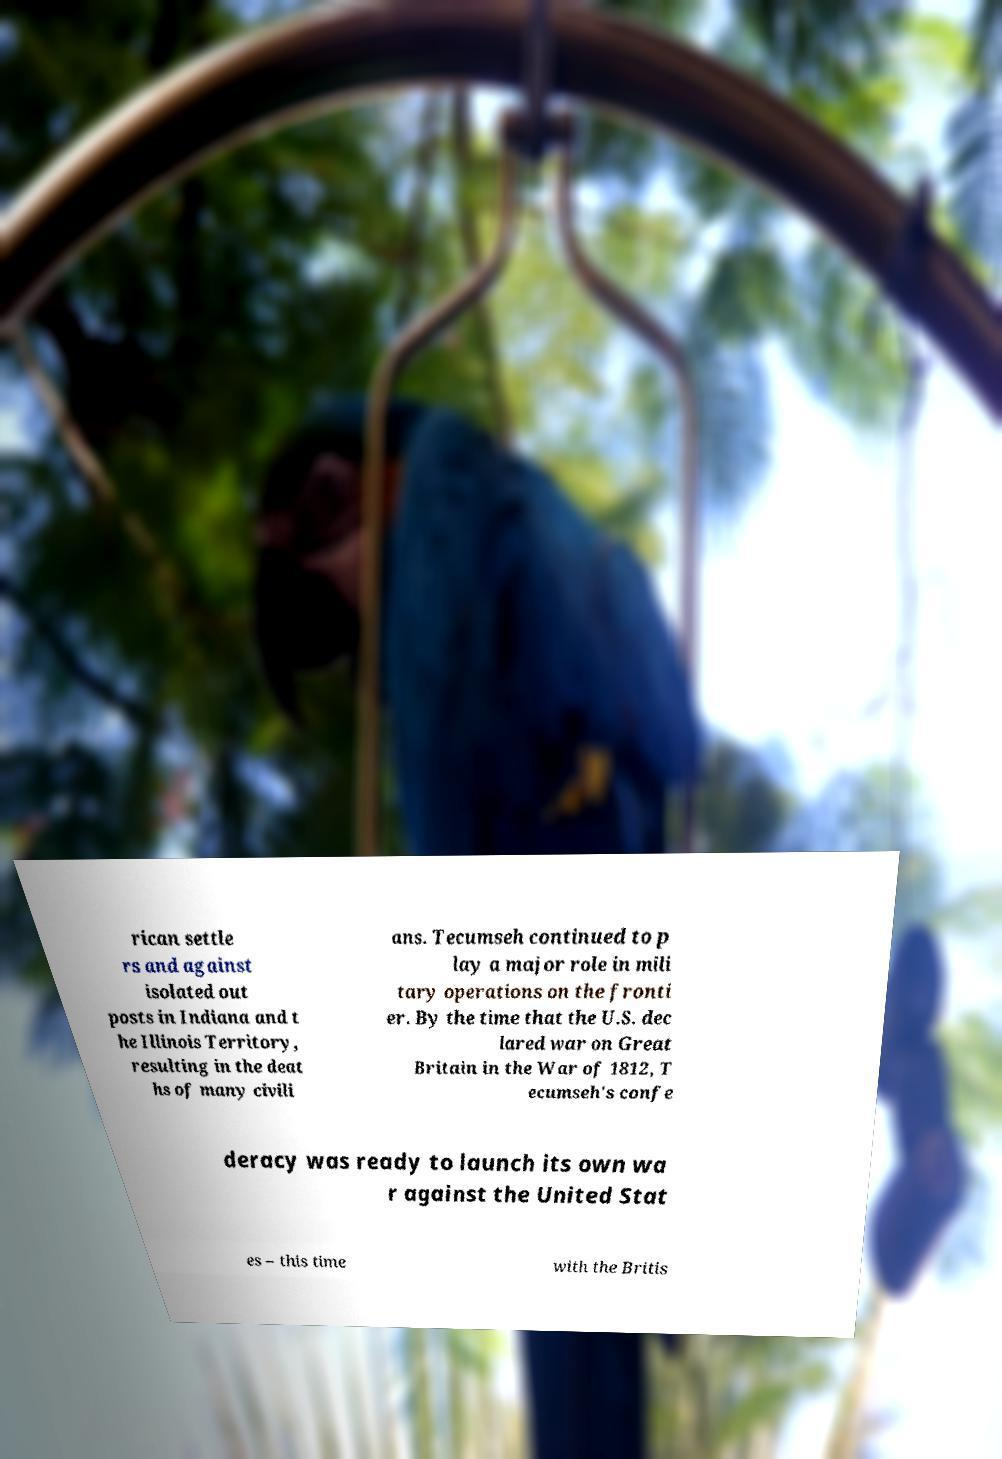There's text embedded in this image that I need extracted. Can you transcribe it verbatim? rican settle rs and against isolated out posts in Indiana and t he Illinois Territory, resulting in the deat hs of many civili ans. Tecumseh continued to p lay a major role in mili tary operations on the fronti er. By the time that the U.S. dec lared war on Great Britain in the War of 1812, T ecumseh's confe deracy was ready to launch its own wa r against the United Stat es – this time with the Britis 